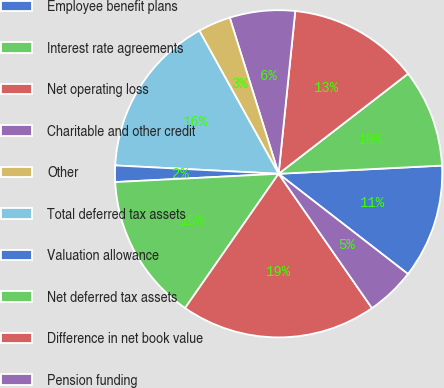<chart> <loc_0><loc_0><loc_500><loc_500><pie_chart><fcel>Employee benefit plans<fcel>Interest rate agreements<fcel>Net operating loss<fcel>Charitable and other credit<fcel>Other<fcel>Total deferred tax assets<fcel>Valuation allowance<fcel>Net deferred tax assets<fcel>Difference in net book value<fcel>Pension funding<nl><fcel>11.29%<fcel>9.68%<fcel>12.9%<fcel>6.45%<fcel>3.23%<fcel>16.13%<fcel>1.62%<fcel>14.51%<fcel>19.35%<fcel>4.84%<nl></chart> 